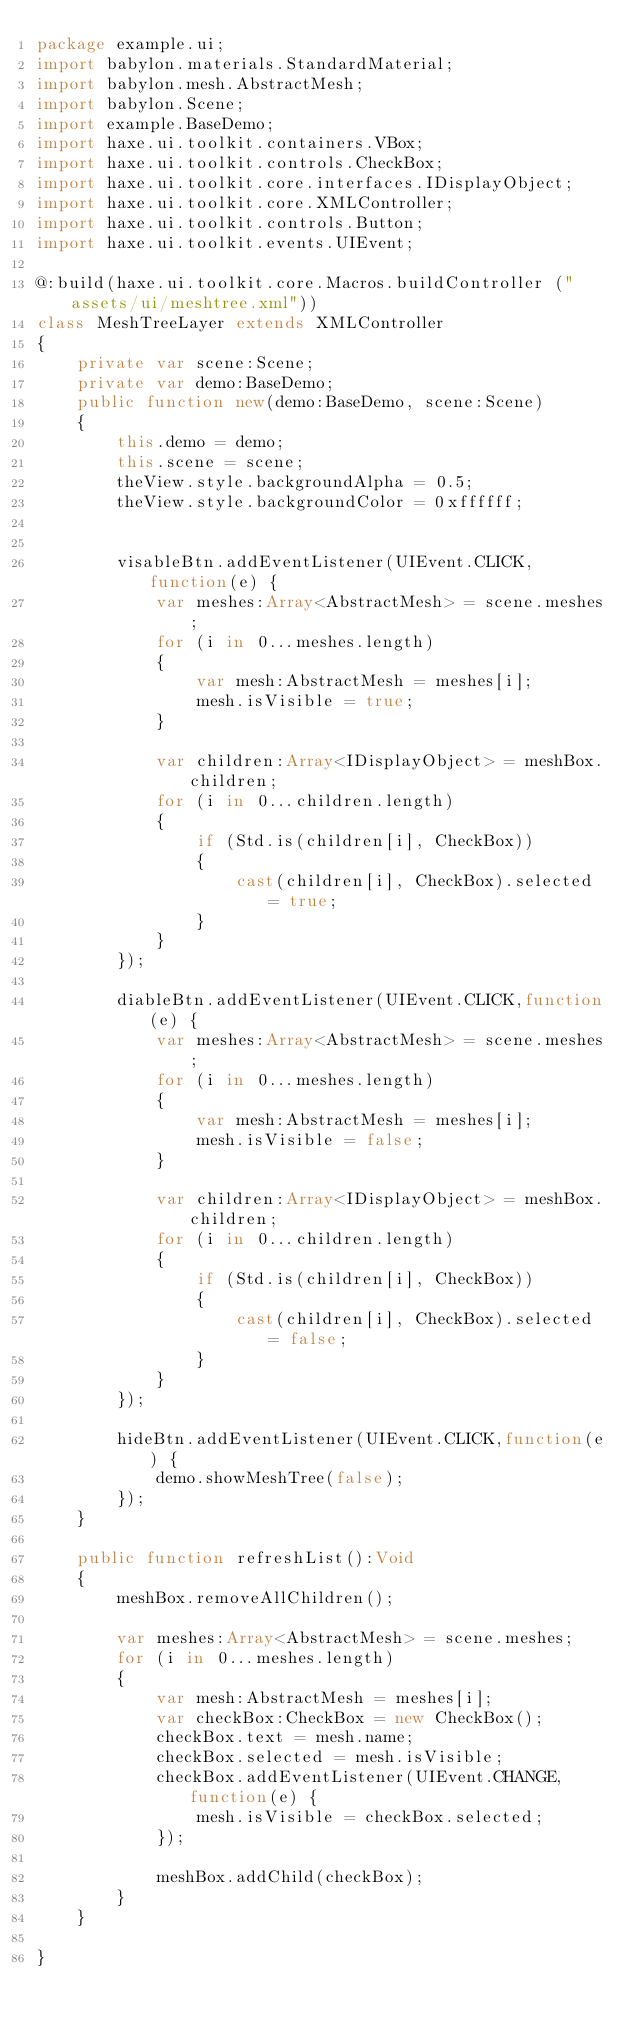Convert code to text. <code><loc_0><loc_0><loc_500><loc_500><_Haxe_>package example.ui;
import babylon.materials.StandardMaterial;
import babylon.mesh.AbstractMesh;
import babylon.Scene;
import example.BaseDemo;
import haxe.ui.toolkit.containers.VBox;
import haxe.ui.toolkit.controls.CheckBox;
import haxe.ui.toolkit.core.interfaces.IDisplayObject;
import haxe.ui.toolkit.core.XMLController;
import haxe.ui.toolkit.controls.Button;
import haxe.ui.toolkit.events.UIEvent;

@:build(haxe.ui.toolkit.core.Macros.buildController ("assets/ui/meshtree.xml"))
class MeshTreeLayer extends XMLController
{
	private var scene:Scene;
	private var demo:BaseDemo;
	public function new(demo:BaseDemo, scene:Scene) 
	{
		this.demo = demo;
		this.scene = scene;
		theView.style.backgroundAlpha = 0.5;
		theView.style.backgroundColor = 0xffffff;
		
		
		visableBtn.addEventListener(UIEvent.CLICK,function(e) {
            var meshes:Array<AbstractMesh> = scene.meshes;
			for (i in 0...meshes.length)
			{
				var mesh:AbstractMesh = meshes[i];
				mesh.isVisible = true;
			}
			
			var children:Array<IDisplayObject> = meshBox.children;
			for (i in 0...children.length)
			{
				if (Std.is(children[i], CheckBox))
				{
					cast(children[i], CheckBox).selected = true;
				}
			}
        });
		
		diableBtn.addEventListener(UIEvent.CLICK,function(e) {
            var meshes:Array<AbstractMesh> = scene.meshes;
			for (i in 0...meshes.length)
			{
				var mesh:AbstractMesh = meshes[i];
				mesh.isVisible = false;
			}

			var children:Array<IDisplayObject> = meshBox.children;
			for (i in 0...children.length)
			{
				if (Std.is(children[i], CheckBox))
				{
					cast(children[i], CheckBox).selected = false;
				}
			}
        });
		
		hideBtn.addEventListener(UIEvent.CLICK,function(e) {
            demo.showMeshTree(false);
        });
	}
	
	public function refreshList():Void
	{
		meshBox.removeAllChildren();
		
		var meshes:Array<AbstractMesh> = scene.meshes;
		for (i in 0...meshes.length)
		{
			var mesh:AbstractMesh = meshes[i];
			var checkBox:CheckBox = new CheckBox();
			checkBox.text = mesh.name;
			checkBox.selected = mesh.isVisible;
			checkBox.addEventListener(UIEvent.CHANGE,function(e) {
				mesh.isVisible = checkBox.selected;
			});
			
			meshBox.addChild(checkBox);
		}
	}
	
}</code> 